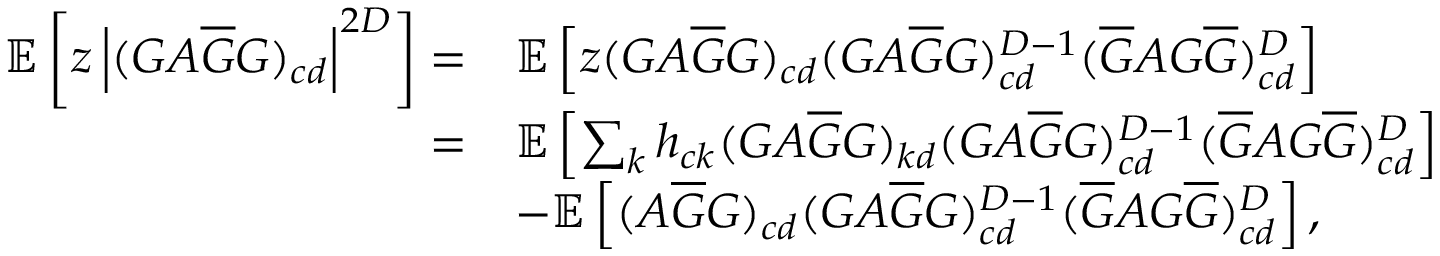Convert formula to latex. <formula><loc_0><loc_0><loc_500><loc_500>\begin{array} { r l } { \mathbb { E } \left [ z \left | ( G A \overline { G } G ) _ { c d } \right | ^ { 2 D } \right ] = } & { \mathbb { E } \left [ z ( G A \overline { G } G ) _ { c d } ( G A \overline { G } G ) _ { c d } ^ { D - 1 } ( \overline { G } A G \overline { G } ) _ { c d } ^ { D } \right ] } \\ { = } & { \mathbb { E } \left [ \sum _ { k } h _ { c k } ( G A \overline { G } G ) _ { k d } ( G A \overline { G } G ) _ { c d } ^ { D - 1 } ( \overline { G } A G \overline { G } ) _ { c d } ^ { D } \right ] } \\ & { - \mathbb { E } \left [ ( A \overline { G } G ) _ { c d } ( G A \overline { G } G ) _ { c d } ^ { D - 1 } ( \overline { G } A G \overline { G } ) _ { c d } ^ { D } \right ] , } \end{array}</formula> 